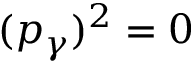Convert formula to latex. <formula><loc_0><loc_0><loc_500><loc_500>( p _ { \gamma } ) ^ { 2 } = 0</formula> 